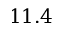Convert formula to latex. <formula><loc_0><loc_0><loc_500><loc_500>1 1 . 4</formula> 